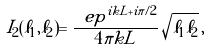<formula> <loc_0><loc_0><loc_500><loc_500>I _ { 2 } ( \ell _ { 1 } , \ell _ { 2 } ) = \frac { \ e p ^ { i k L + i \pi / 2 } } { 4 \pi k L } \, \sqrt { \ell _ { 1 } \ell _ { 2 } } \, ,</formula> 